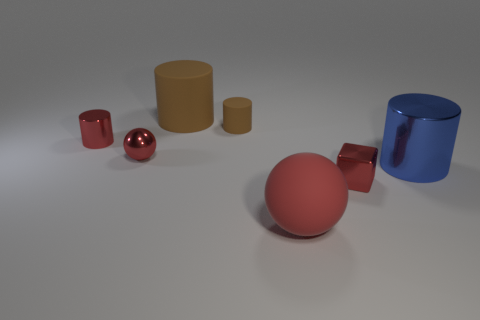What is the shape of the rubber object that is the same color as the small metal sphere?
Provide a short and direct response. Sphere. The small cube has what color?
Your answer should be compact. Red. There is a red metallic sphere that is in front of the small metal cylinder; what size is it?
Your answer should be compact. Small. What number of metallic cylinders are in front of the big rubber thing behind the metal cylinder behind the big blue shiny cylinder?
Your answer should be compact. 2. The small cylinder to the right of the metal cylinder that is left of the large brown thing is what color?
Offer a very short reply. Brown. Is there a red object of the same size as the blue metallic thing?
Provide a short and direct response. Yes. The tiny object left of the ball that is behind the red metallic thing that is on the right side of the large brown matte cylinder is made of what material?
Ensure brevity in your answer.  Metal. There is a metal cylinder behind the big blue cylinder; how many large blue cylinders are to the left of it?
Ensure brevity in your answer.  0. There is a red object behind the metallic sphere; is it the same size as the large brown rubber object?
Your answer should be compact. No. What number of other red rubber things have the same shape as the large red rubber object?
Your response must be concise. 0. 